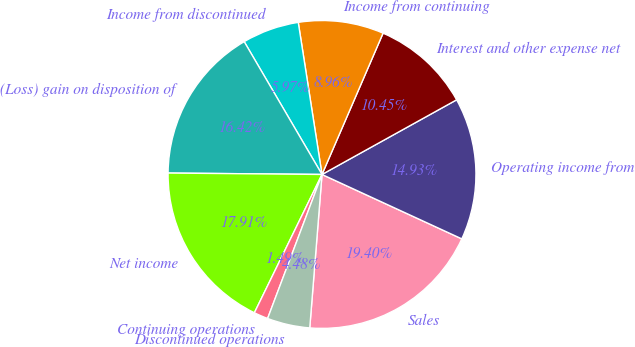<chart> <loc_0><loc_0><loc_500><loc_500><pie_chart><fcel>Sales<fcel>Operating income from<fcel>Interest and other expense net<fcel>Income from continuing<fcel>Income from discontinued<fcel>(Loss) gain on disposition of<fcel>Net income<fcel>Continuing operations<fcel>Discontinued operations<nl><fcel>19.4%<fcel>14.93%<fcel>10.45%<fcel>8.96%<fcel>5.97%<fcel>16.42%<fcel>17.91%<fcel>1.49%<fcel>4.48%<nl></chart> 